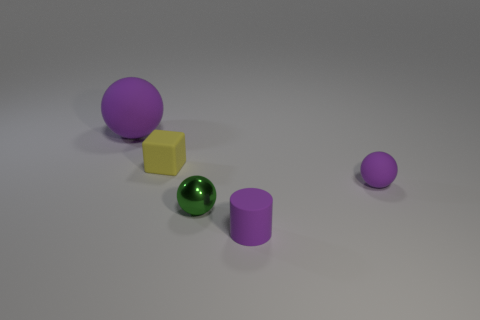Add 1 big red metal things. How many objects exist? 6 Subtract all purple spheres. How many spheres are left? 1 Subtract all purple balls. How many balls are left? 1 Subtract all balls. How many objects are left? 2 Subtract all purple cylinders. How many green balls are left? 1 Subtract all blue cylinders. Subtract all brown blocks. How many cylinders are left? 1 Subtract all big purple things. Subtract all tiny purple matte cylinders. How many objects are left? 3 Add 3 shiny things. How many shiny things are left? 4 Add 5 small gray metallic things. How many small gray metallic things exist? 5 Subtract 0 brown blocks. How many objects are left? 5 